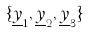<formula> <loc_0><loc_0><loc_500><loc_500>\{ \underline { y } _ { 1 } , \underline { y } _ { 2 } , \underline { y } _ { 3 } \}</formula> 